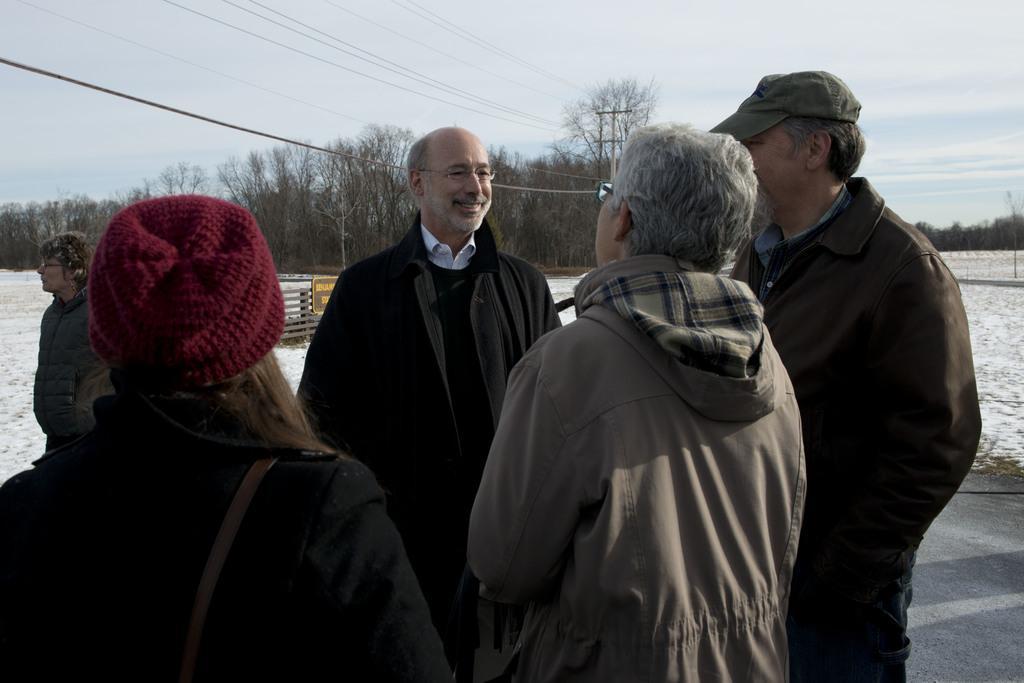How would you summarize this image in a sentence or two? In this image, there are a few people. We can see the ground. We can see some snow and a board with some text. There are a few trees and a pole with some wires. We can also see the sky with clouds. 